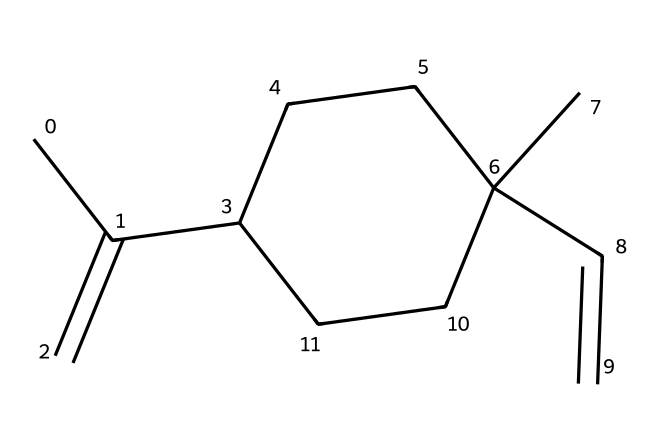What is the molecular formula of limonene? To determine the molecular formula, count the number of carbon (C) and hydrogen (H) atoms represented in the SMILES. There are 10 carbon atoms and 16 hydrogen atoms, resulting in the molecular formula C10H16.
Answer: C10H16 How many rings are present in the structure of limonene? By examining the SMILES representation, we can see that there is one cycloalkane structure indicated by the presence of a number (1) which denotes a cyclic part of the molecule. Hence, there is one ring in limonene.
Answer: 1 What type of hydrocarbon is limonene classified as? Limonene contains multiple carbon-carbon double bonds (notably in the chain) and at least one ring structure, which categorizes it as a cycloalkene.
Answer: cycloalkene How many double bonds are in limonene? Looking at the structure indicated by the SMILES, there are two occurrences of double bond representations, specifically between carbons, confirming the presence of two C=C double bonds in limonene.
Answer: 2 What is the characteristic scent associated with limonene? Limonene is commonly known for its citrus scent, which is particularly noted in the context of cleaning products that often highlight its pleasant fragrance.
Answer: citrus Does limonene exhibit any structural isomerism? Yes, limonene can exist in two isomeric forms (D-limonene and L-limonene) based on the spatial arrangement of atoms around the double bonds, indicating the potential for structural isomerism in this molecule.
Answer: yes 